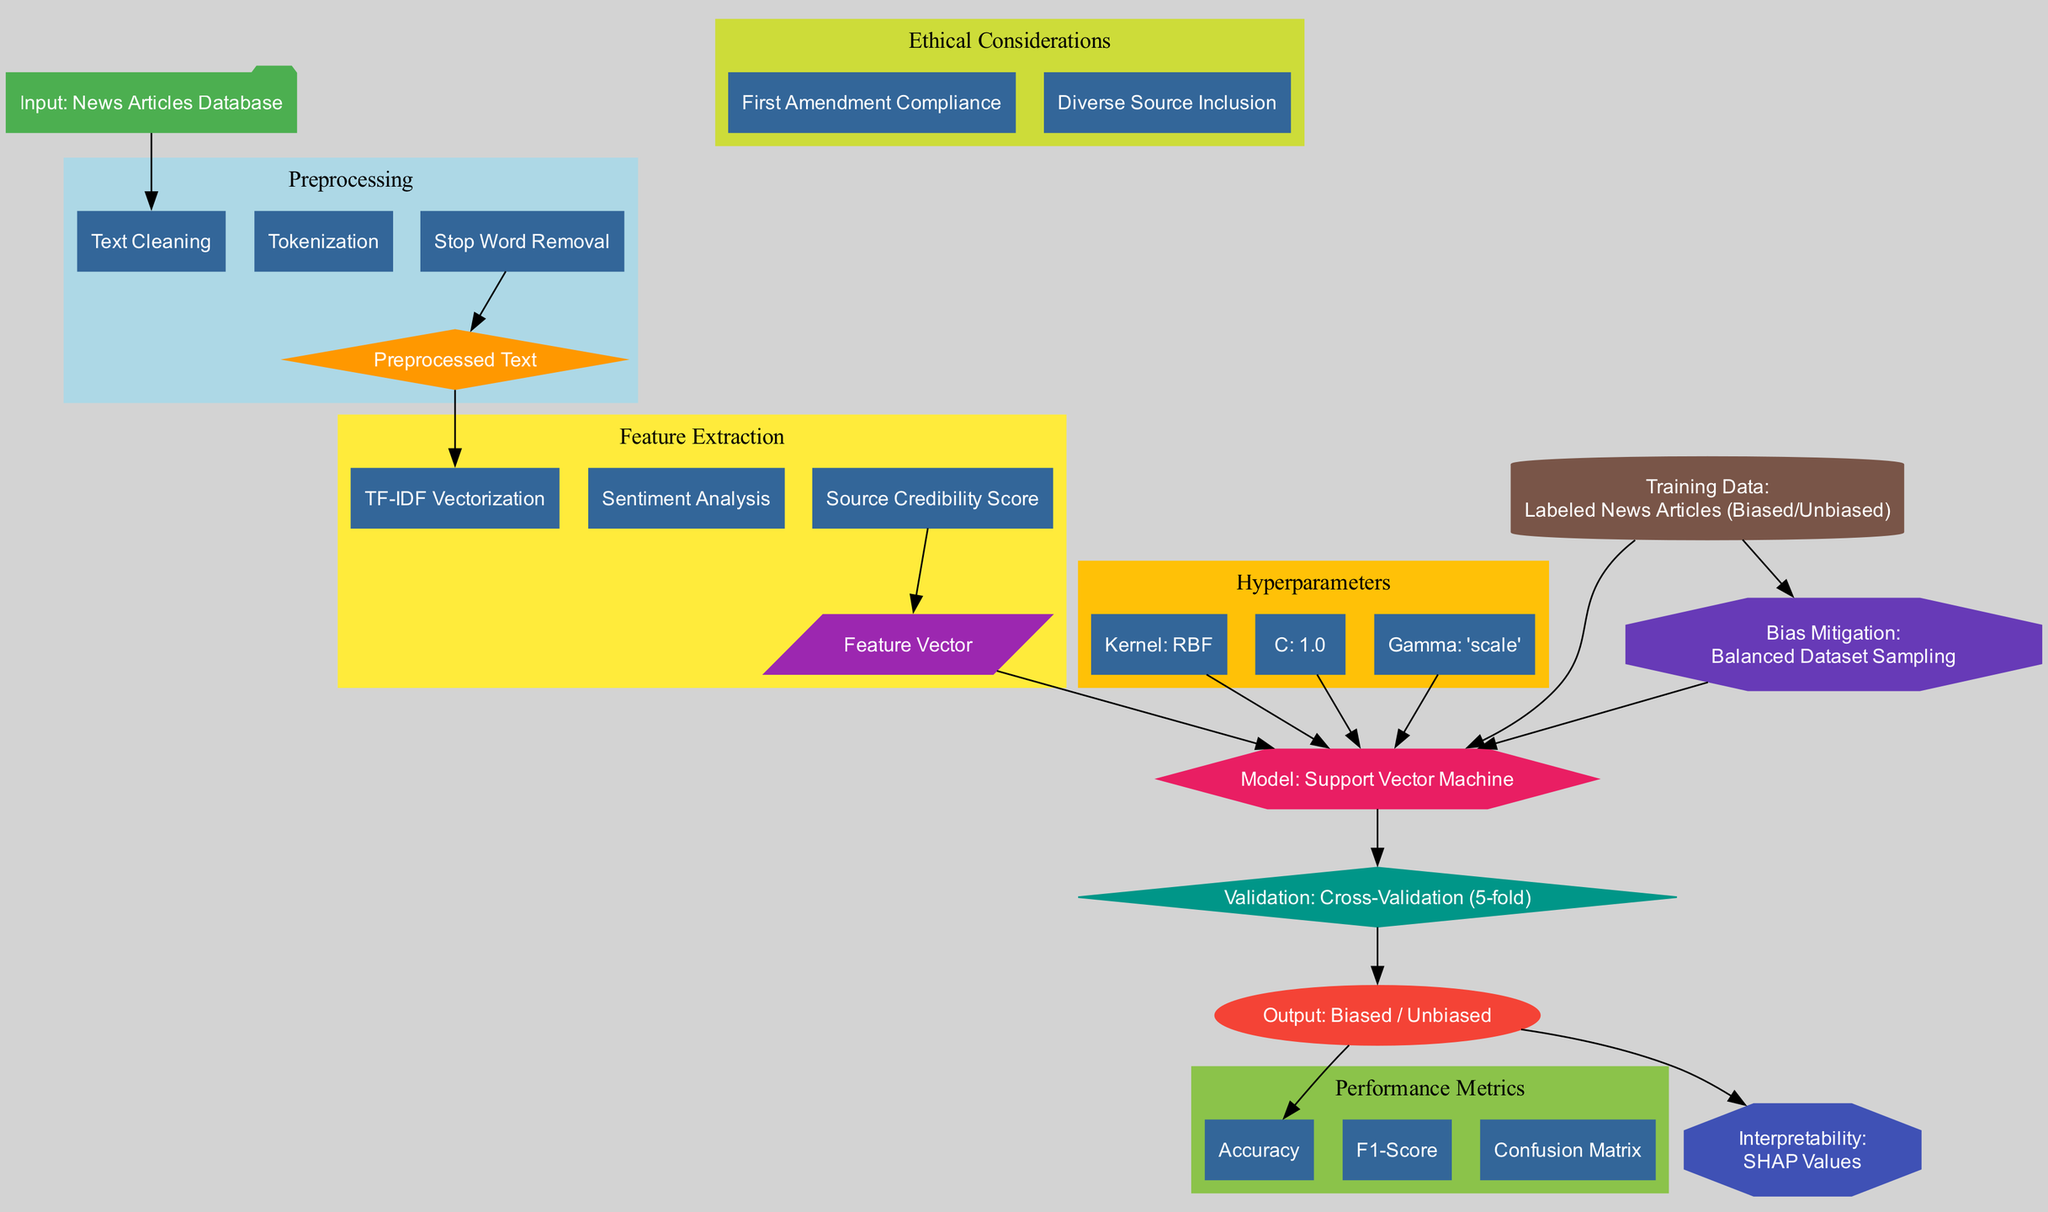What is the model used in this diagram? The diagram explicitly states "Model: Support Vector Machine" as the node representing the model used. Therefore, it can be directly referenced from the diagram.
Answer: Support Vector Machine How many preprocessing steps are listed in the diagram? By counting the steps under the "Preprocessing" block, which are: "Text Cleaning", "Tokenization", and "Stop Word Removal", we see that there are three steps.
Answer: 3 What type of kernel is used for the model in this diagram? The hyperparameters section of the diagram specifies "Kernel: RBF", which identifies the type of kernel employed in the Support Vector Machine model.
Answer: RBF Which node indicates the output categories of the model? The "Output" node clearly indicates that the results of the classification are "Biased / Unbiased", which displays the categories provided by the model.
Answer: Biased / Unbiased What validation method is mentioned in the diagram? The "Validation" node specifies "Cross-Validation (5-fold)", showing the method employed to validate the model's performance.
Answer: Cross-Validation (5-fold) What technique is used for bias mitigation in the diagram? The node labeled "Bias Mitigation" states "Balanced Dataset Sampling", which describes the method used to address bias in the training data.
Answer: Balanced Dataset Sampling How many performance metrics are included in the diagram? The "Performance Metrics" cluster contains "Accuracy", "F1-Score", and "Confusion Matrix", which totals to three distinct metrics.
Answer: 3 What is the ethical consideration highlighted regarding the First Amendment? One of the ethical considerations in the diagram includes "First Amendment Compliance", indicating a direct reference to the importance of free speech in its ethical context.
Answer: First Amendment Compliance Which component of the diagram uses SHAP values for interpretability? The node labeled "Interpretability" mentions "SHAP Values", which signifies its use in understanding model outcomes.
Answer: SHAP Values 